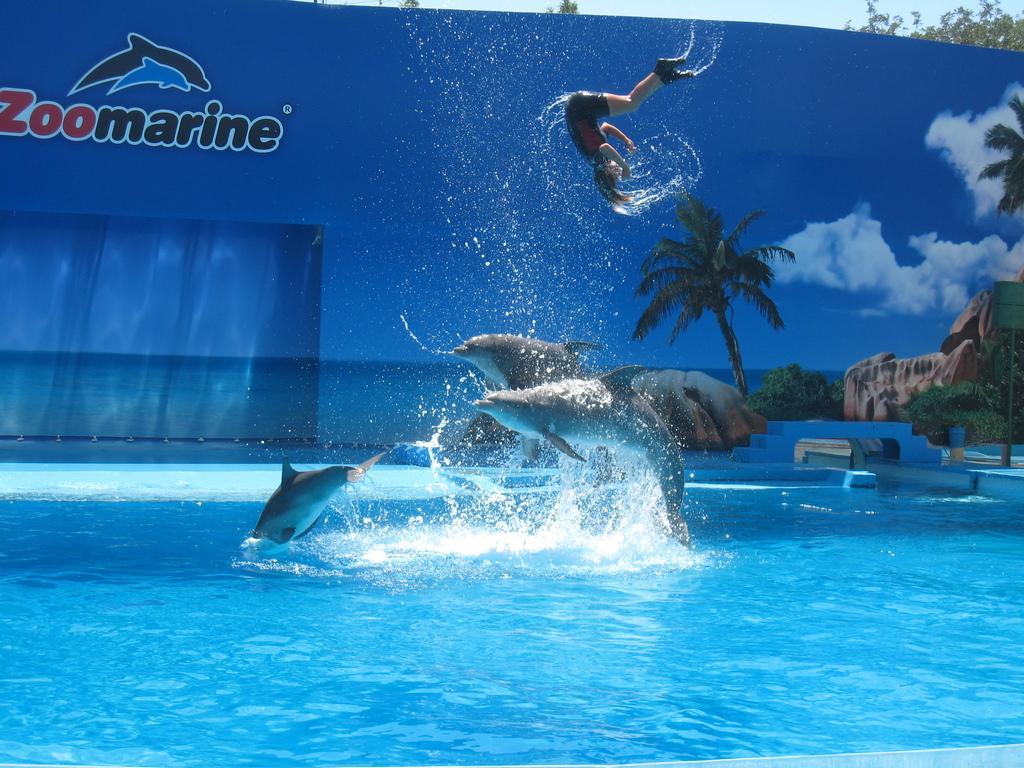Can you describe this image briefly? In this image, I can see the dolphins and a person jumping above the water. In the background, there is a board with the words, logo, pictures of trees, sky and rocks. On the right side of the image, I can see a bench. 